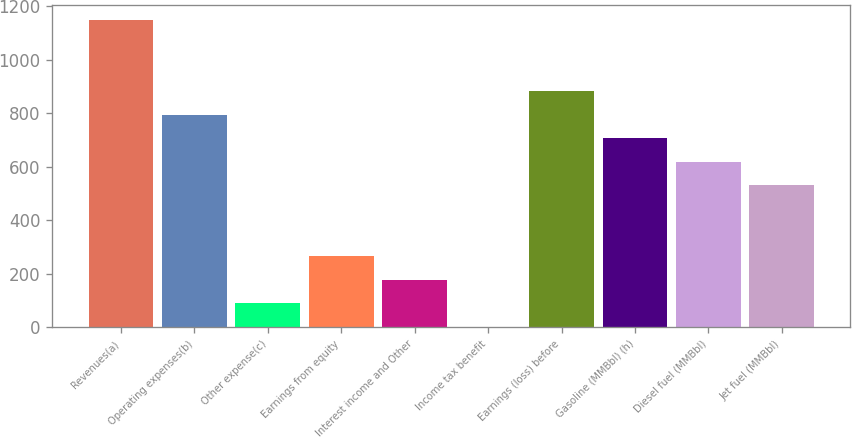Convert chart. <chart><loc_0><loc_0><loc_500><loc_500><bar_chart><fcel>Revenues(a)<fcel>Operating expenses(b)<fcel>Other expense(c)<fcel>Earnings from equity<fcel>Interest income and Other<fcel>Income tax benefit<fcel>Earnings (loss) before<fcel>Gasoline (MMBbl) (h)<fcel>Diesel fuel (MMBbl)<fcel>Jet fuel (MMBbl)<nl><fcel>1147.57<fcel>794.81<fcel>89.29<fcel>265.67<fcel>177.48<fcel>1.1<fcel>883<fcel>706.62<fcel>618.43<fcel>530.24<nl></chart> 